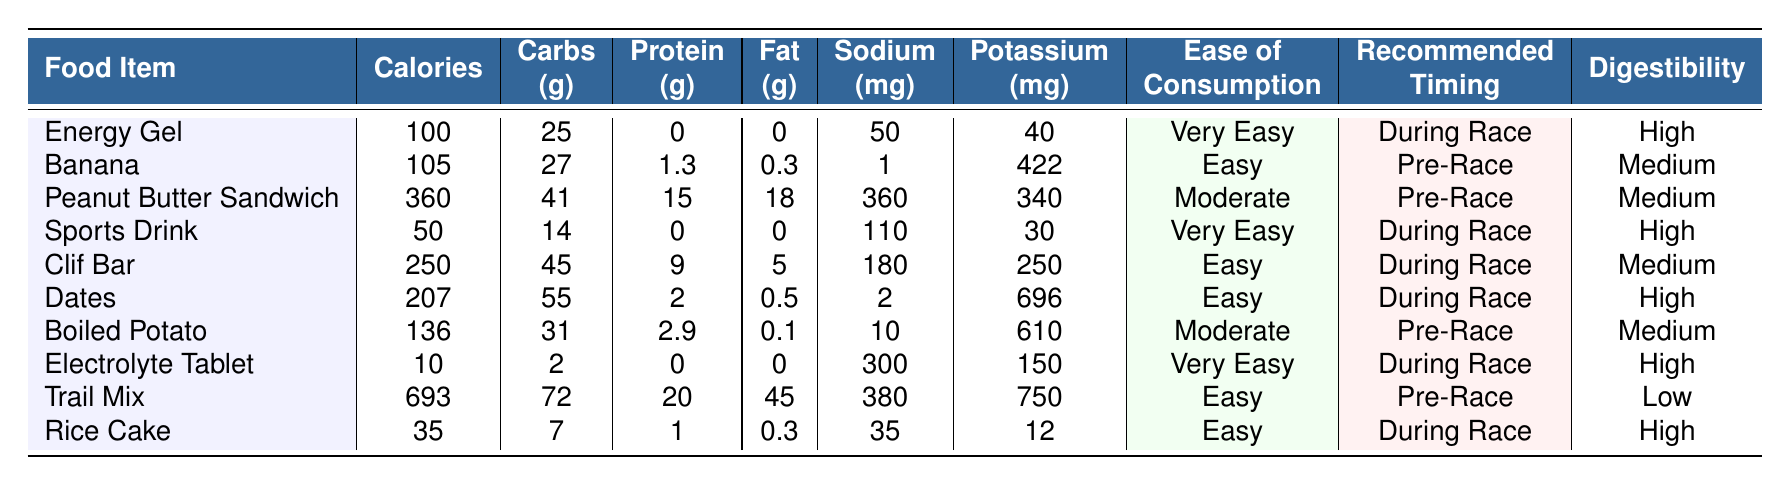What food item has the highest calories? The food item with the highest calories can be identified by looking at the "Calories" column. The highest value is 693, which corresponds to "Trail Mix."
Answer: Trail Mix Which food items are recommended for consumption during a race? To find the food items identified for consumption during a race, we refer to the "Recommended Timing" column and look for entries labeled "During Race." The items are: Energy Gel, Sports Drink, Clif Bar, Dates, Electrolyte Tablet, and Rice Cake.
Answer: Energy Gel, Sports Drink, Clif Bar, Dates, Electrolyte Tablet, Rice Cake What is the total carbohydrate content in the Peanut Butter Sandwich and Clif Bar? We need to sum the carbohydrate contents of both food items. The Peanut Butter Sandwich has 41 g, and the Clif Bar has 45 g, which gives a total of 41 + 45 = 86 g.
Answer: 86 g Is the digestibility of the Trail Mix high? We can check the "Digestibility" column for "Trail Mix." It shows "Low," thus confirming that its digestibility is not high.
Answer: No What is the average sodium content of all food items? To find the average sodium content, we first sum all sodium values: 50 + 1 + 360 + 110 + 180 + 2 + 10 + 300 + 380 + 35 = 1028 mg. Since there are 10 food items, we divide the total by 10: 1028/10 = 102.8 mg.
Answer: 102.8 mg Which food item contains the most protein per serving? We identify the maximum protein content in the "Protein (g)" column, where "Trail Mix" has 20 g, which is the highest value.
Answer: Trail Mix Is Banana higher in potassium than Sports Drink? By checking the "Potassium (mg)" column, we see Banana has 422 mg and Sports Drink has 30 mg. Since 422 is greater than 30, the answer is affirmative.
Answer: Yes How many food items have a "Very Easy" ease of consumption? We can count the entries in the "Ease of Consumption" column that are marked "Very Easy." The items are Energy Gel, Sports Drink, and Electrolyte Tablet, totaling 3 items.
Answer: 3 What is the difference in calories between the Clif Bar and the Rice Cake? To find the difference, we subtract the calories of Rice Cake (35) from Clif Bar (250): 250 - 35 = 215.
Answer: 215 Do all items labeled "During Race" have high digestibility? We check the "Digestibility" of the food items with "During Race". The items with high digestibility are Energy Gel, Sports Drink, Dates, and Electrolyte Tablet, while Clif Bar and Rice Cake do not have high digestibility. Therefore, not all items labeled "During Race" have high digestibility.
Answer: No 